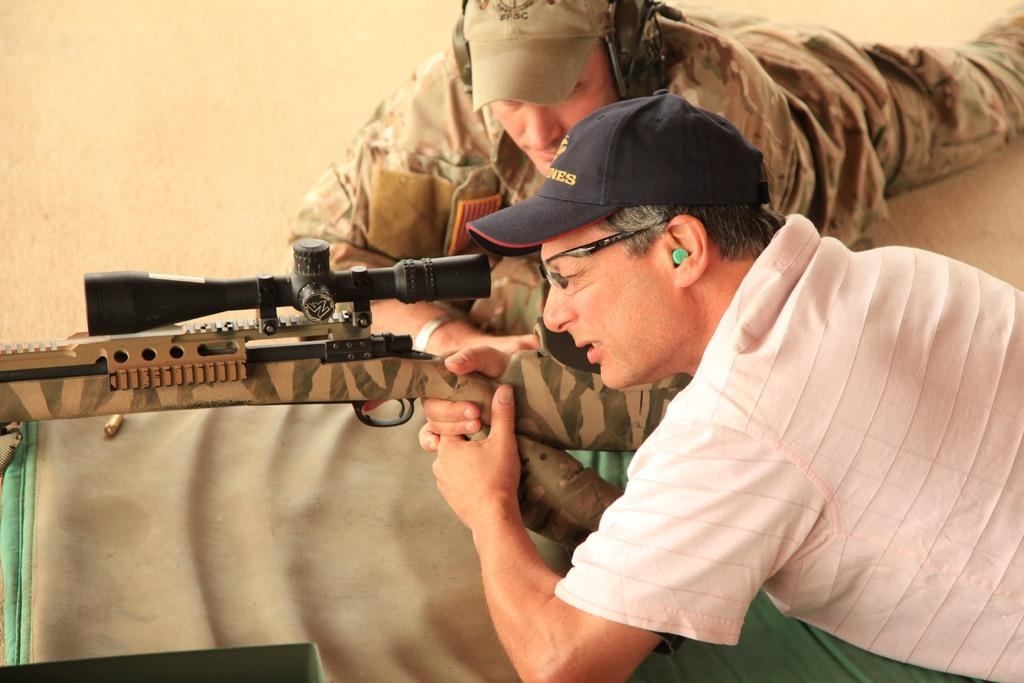How many persons are in the image? There are persons in the image. What are the persons wearing? The persons are wearing clothes and caps. Can you describe the person on the right side of the image? The person on the right side of the image is holding a gun with their hands. What is at the bottom of the image? There is a cloth at the bottom of the image. What type of camp can be seen in the image? There is no camp present in the image. What does the queen use the gun for in the image? There is no queen present in the image, and the person holding the gun is not identified as a queen. 